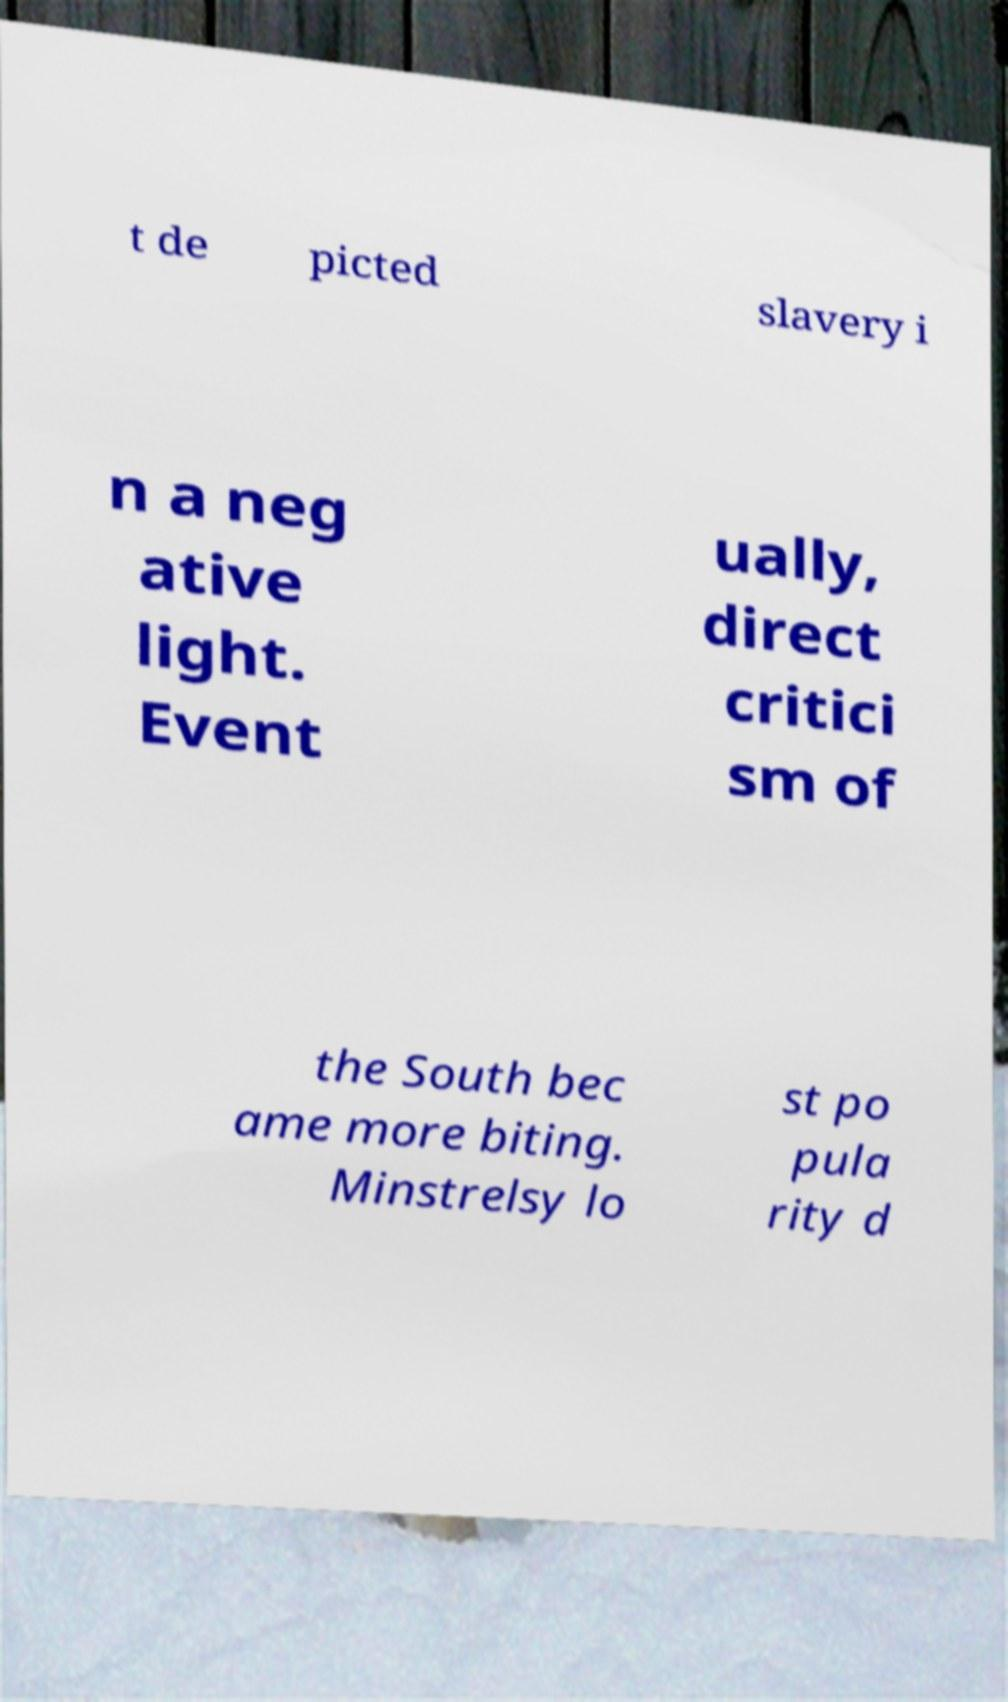There's text embedded in this image that I need extracted. Can you transcribe it verbatim? t de picted slavery i n a neg ative light. Event ually, direct critici sm of the South bec ame more biting. Minstrelsy lo st po pula rity d 